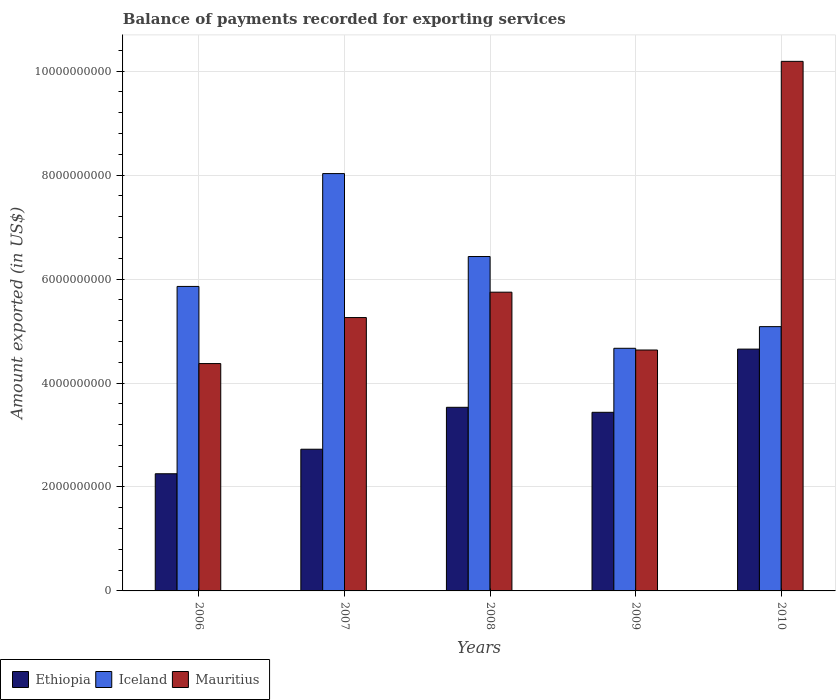How many bars are there on the 4th tick from the left?
Provide a short and direct response. 3. How many bars are there on the 2nd tick from the right?
Ensure brevity in your answer.  3. In how many cases, is the number of bars for a given year not equal to the number of legend labels?
Your answer should be very brief. 0. What is the amount exported in Mauritius in 2006?
Provide a short and direct response. 4.37e+09. Across all years, what is the maximum amount exported in Ethiopia?
Your response must be concise. 4.65e+09. Across all years, what is the minimum amount exported in Mauritius?
Your answer should be very brief. 4.37e+09. In which year was the amount exported in Ethiopia maximum?
Give a very brief answer. 2010. What is the total amount exported in Ethiopia in the graph?
Your answer should be very brief. 1.66e+1. What is the difference between the amount exported in Iceland in 2006 and that in 2007?
Your response must be concise. -2.17e+09. What is the difference between the amount exported in Ethiopia in 2007 and the amount exported in Mauritius in 2008?
Provide a short and direct response. -3.02e+09. What is the average amount exported in Iceland per year?
Offer a very short reply. 6.01e+09. In the year 2006, what is the difference between the amount exported in Ethiopia and amount exported in Mauritius?
Provide a succinct answer. -2.12e+09. In how many years, is the amount exported in Ethiopia greater than 9200000000 US$?
Provide a short and direct response. 0. What is the ratio of the amount exported in Ethiopia in 2006 to that in 2009?
Your response must be concise. 0.66. Is the amount exported in Mauritius in 2007 less than that in 2009?
Your answer should be very brief. No. What is the difference between the highest and the second highest amount exported in Ethiopia?
Keep it short and to the point. 1.12e+09. What is the difference between the highest and the lowest amount exported in Iceland?
Give a very brief answer. 3.36e+09. Is the sum of the amount exported in Iceland in 2007 and 2008 greater than the maximum amount exported in Mauritius across all years?
Make the answer very short. Yes. What does the 2nd bar from the left in 2008 represents?
Offer a very short reply. Iceland. What does the 1st bar from the right in 2007 represents?
Make the answer very short. Mauritius. How many bars are there?
Give a very brief answer. 15. What is the difference between two consecutive major ticks on the Y-axis?
Provide a short and direct response. 2.00e+09. Where does the legend appear in the graph?
Provide a succinct answer. Bottom left. How are the legend labels stacked?
Provide a short and direct response. Horizontal. What is the title of the graph?
Offer a terse response. Balance of payments recorded for exporting services. Does "Solomon Islands" appear as one of the legend labels in the graph?
Offer a terse response. No. What is the label or title of the Y-axis?
Keep it short and to the point. Amount exported (in US$). What is the Amount exported (in US$) in Ethiopia in 2006?
Ensure brevity in your answer.  2.25e+09. What is the Amount exported (in US$) of Iceland in 2006?
Provide a short and direct response. 5.86e+09. What is the Amount exported (in US$) in Mauritius in 2006?
Keep it short and to the point. 4.37e+09. What is the Amount exported (in US$) of Ethiopia in 2007?
Your answer should be very brief. 2.73e+09. What is the Amount exported (in US$) of Iceland in 2007?
Keep it short and to the point. 8.03e+09. What is the Amount exported (in US$) of Mauritius in 2007?
Offer a terse response. 5.26e+09. What is the Amount exported (in US$) in Ethiopia in 2008?
Your answer should be very brief. 3.53e+09. What is the Amount exported (in US$) of Iceland in 2008?
Keep it short and to the point. 6.43e+09. What is the Amount exported (in US$) of Mauritius in 2008?
Keep it short and to the point. 5.75e+09. What is the Amount exported (in US$) of Ethiopia in 2009?
Give a very brief answer. 3.44e+09. What is the Amount exported (in US$) of Iceland in 2009?
Ensure brevity in your answer.  4.67e+09. What is the Amount exported (in US$) of Mauritius in 2009?
Offer a terse response. 4.64e+09. What is the Amount exported (in US$) of Ethiopia in 2010?
Make the answer very short. 4.65e+09. What is the Amount exported (in US$) of Iceland in 2010?
Give a very brief answer. 5.08e+09. What is the Amount exported (in US$) in Mauritius in 2010?
Provide a succinct answer. 1.02e+1. Across all years, what is the maximum Amount exported (in US$) of Ethiopia?
Your answer should be compact. 4.65e+09. Across all years, what is the maximum Amount exported (in US$) in Iceland?
Offer a terse response. 8.03e+09. Across all years, what is the maximum Amount exported (in US$) in Mauritius?
Your answer should be very brief. 1.02e+1. Across all years, what is the minimum Amount exported (in US$) in Ethiopia?
Your answer should be very brief. 2.25e+09. Across all years, what is the minimum Amount exported (in US$) of Iceland?
Ensure brevity in your answer.  4.67e+09. Across all years, what is the minimum Amount exported (in US$) of Mauritius?
Your answer should be very brief. 4.37e+09. What is the total Amount exported (in US$) in Ethiopia in the graph?
Offer a terse response. 1.66e+1. What is the total Amount exported (in US$) in Iceland in the graph?
Your answer should be compact. 3.01e+1. What is the total Amount exported (in US$) in Mauritius in the graph?
Your answer should be very brief. 3.02e+1. What is the difference between the Amount exported (in US$) of Ethiopia in 2006 and that in 2007?
Give a very brief answer. -4.72e+08. What is the difference between the Amount exported (in US$) of Iceland in 2006 and that in 2007?
Your answer should be compact. -2.17e+09. What is the difference between the Amount exported (in US$) of Mauritius in 2006 and that in 2007?
Your response must be concise. -8.85e+08. What is the difference between the Amount exported (in US$) in Ethiopia in 2006 and that in 2008?
Your answer should be very brief. -1.28e+09. What is the difference between the Amount exported (in US$) in Iceland in 2006 and that in 2008?
Offer a terse response. -5.76e+08. What is the difference between the Amount exported (in US$) of Mauritius in 2006 and that in 2008?
Give a very brief answer. -1.37e+09. What is the difference between the Amount exported (in US$) in Ethiopia in 2006 and that in 2009?
Ensure brevity in your answer.  -1.18e+09. What is the difference between the Amount exported (in US$) of Iceland in 2006 and that in 2009?
Offer a very short reply. 1.19e+09. What is the difference between the Amount exported (in US$) of Mauritius in 2006 and that in 2009?
Provide a succinct answer. -2.61e+08. What is the difference between the Amount exported (in US$) in Ethiopia in 2006 and that in 2010?
Make the answer very short. -2.40e+09. What is the difference between the Amount exported (in US$) in Iceland in 2006 and that in 2010?
Offer a very short reply. 7.73e+08. What is the difference between the Amount exported (in US$) of Mauritius in 2006 and that in 2010?
Ensure brevity in your answer.  -5.81e+09. What is the difference between the Amount exported (in US$) in Ethiopia in 2007 and that in 2008?
Your answer should be very brief. -8.07e+08. What is the difference between the Amount exported (in US$) of Iceland in 2007 and that in 2008?
Offer a terse response. 1.60e+09. What is the difference between the Amount exported (in US$) of Mauritius in 2007 and that in 2008?
Your answer should be compact. -4.88e+08. What is the difference between the Amount exported (in US$) in Ethiopia in 2007 and that in 2009?
Offer a very short reply. -7.10e+08. What is the difference between the Amount exported (in US$) of Iceland in 2007 and that in 2009?
Keep it short and to the point. 3.36e+09. What is the difference between the Amount exported (in US$) of Mauritius in 2007 and that in 2009?
Keep it short and to the point. 6.24e+08. What is the difference between the Amount exported (in US$) in Ethiopia in 2007 and that in 2010?
Provide a short and direct response. -1.93e+09. What is the difference between the Amount exported (in US$) in Iceland in 2007 and that in 2010?
Ensure brevity in your answer.  2.94e+09. What is the difference between the Amount exported (in US$) in Mauritius in 2007 and that in 2010?
Give a very brief answer. -4.93e+09. What is the difference between the Amount exported (in US$) in Ethiopia in 2008 and that in 2009?
Your answer should be very brief. 9.64e+07. What is the difference between the Amount exported (in US$) of Iceland in 2008 and that in 2009?
Provide a succinct answer. 1.77e+09. What is the difference between the Amount exported (in US$) in Mauritius in 2008 and that in 2009?
Offer a terse response. 1.11e+09. What is the difference between the Amount exported (in US$) in Ethiopia in 2008 and that in 2010?
Your response must be concise. -1.12e+09. What is the difference between the Amount exported (in US$) of Iceland in 2008 and that in 2010?
Keep it short and to the point. 1.35e+09. What is the difference between the Amount exported (in US$) in Mauritius in 2008 and that in 2010?
Offer a very short reply. -4.44e+09. What is the difference between the Amount exported (in US$) in Ethiopia in 2009 and that in 2010?
Your response must be concise. -1.22e+09. What is the difference between the Amount exported (in US$) of Iceland in 2009 and that in 2010?
Ensure brevity in your answer.  -4.17e+08. What is the difference between the Amount exported (in US$) in Mauritius in 2009 and that in 2010?
Ensure brevity in your answer.  -5.55e+09. What is the difference between the Amount exported (in US$) of Ethiopia in 2006 and the Amount exported (in US$) of Iceland in 2007?
Make the answer very short. -5.77e+09. What is the difference between the Amount exported (in US$) in Ethiopia in 2006 and the Amount exported (in US$) in Mauritius in 2007?
Give a very brief answer. -3.01e+09. What is the difference between the Amount exported (in US$) in Iceland in 2006 and the Amount exported (in US$) in Mauritius in 2007?
Offer a very short reply. 5.99e+08. What is the difference between the Amount exported (in US$) in Ethiopia in 2006 and the Amount exported (in US$) in Iceland in 2008?
Provide a short and direct response. -4.18e+09. What is the difference between the Amount exported (in US$) of Ethiopia in 2006 and the Amount exported (in US$) of Mauritius in 2008?
Give a very brief answer. -3.49e+09. What is the difference between the Amount exported (in US$) in Iceland in 2006 and the Amount exported (in US$) in Mauritius in 2008?
Make the answer very short. 1.10e+08. What is the difference between the Amount exported (in US$) in Ethiopia in 2006 and the Amount exported (in US$) in Iceland in 2009?
Provide a short and direct response. -2.41e+09. What is the difference between the Amount exported (in US$) of Ethiopia in 2006 and the Amount exported (in US$) of Mauritius in 2009?
Keep it short and to the point. -2.38e+09. What is the difference between the Amount exported (in US$) in Iceland in 2006 and the Amount exported (in US$) in Mauritius in 2009?
Offer a terse response. 1.22e+09. What is the difference between the Amount exported (in US$) of Ethiopia in 2006 and the Amount exported (in US$) of Iceland in 2010?
Provide a short and direct response. -2.83e+09. What is the difference between the Amount exported (in US$) in Ethiopia in 2006 and the Amount exported (in US$) in Mauritius in 2010?
Your answer should be compact. -7.93e+09. What is the difference between the Amount exported (in US$) in Iceland in 2006 and the Amount exported (in US$) in Mauritius in 2010?
Provide a succinct answer. -4.33e+09. What is the difference between the Amount exported (in US$) of Ethiopia in 2007 and the Amount exported (in US$) of Iceland in 2008?
Your answer should be very brief. -3.71e+09. What is the difference between the Amount exported (in US$) of Ethiopia in 2007 and the Amount exported (in US$) of Mauritius in 2008?
Your response must be concise. -3.02e+09. What is the difference between the Amount exported (in US$) of Iceland in 2007 and the Amount exported (in US$) of Mauritius in 2008?
Offer a terse response. 2.28e+09. What is the difference between the Amount exported (in US$) of Ethiopia in 2007 and the Amount exported (in US$) of Iceland in 2009?
Provide a short and direct response. -1.94e+09. What is the difference between the Amount exported (in US$) in Ethiopia in 2007 and the Amount exported (in US$) in Mauritius in 2009?
Keep it short and to the point. -1.91e+09. What is the difference between the Amount exported (in US$) in Iceland in 2007 and the Amount exported (in US$) in Mauritius in 2009?
Make the answer very short. 3.39e+09. What is the difference between the Amount exported (in US$) of Ethiopia in 2007 and the Amount exported (in US$) of Iceland in 2010?
Offer a very short reply. -2.36e+09. What is the difference between the Amount exported (in US$) of Ethiopia in 2007 and the Amount exported (in US$) of Mauritius in 2010?
Ensure brevity in your answer.  -7.46e+09. What is the difference between the Amount exported (in US$) of Iceland in 2007 and the Amount exported (in US$) of Mauritius in 2010?
Your response must be concise. -2.16e+09. What is the difference between the Amount exported (in US$) in Ethiopia in 2008 and the Amount exported (in US$) in Iceland in 2009?
Your response must be concise. -1.14e+09. What is the difference between the Amount exported (in US$) in Ethiopia in 2008 and the Amount exported (in US$) in Mauritius in 2009?
Ensure brevity in your answer.  -1.10e+09. What is the difference between the Amount exported (in US$) of Iceland in 2008 and the Amount exported (in US$) of Mauritius in 2009?
Keep it short and to the point. 1.80e+09. What is the difference between the Amount exported (in US$) in Ethiopia in 2008 and the Amount exported (in US$) in Iceland in 2010?
Give a very brief answer. -1.55e+09. What is the difference between the Amount exported (in US$) of Ethiopia in 2008 and the Amount exported (in US$) of Mauritius in 2010?
Offer a very short reply. -6.66e+09. What is the difference between the Amount exported (in US$) of Iceland in 2008 and the Amount exported (in US$) of Mauritius in 2010?
Ensure brevity in your answer.  -3.75e+09. What is the difference between the Amount exported (in US$) of Ethiopia in 2009 and the Amount exported (in US$) of Iceland in 2010?
Your answer should be compact. -1.65e+09. What is the difference between the Amount exported (in US$) of Ethiopia in 2009 and the Amount exported (in US$) of Mauritius in 2010?
Give a very brief answer. -6.75e+09. What is the difference between the Amount exported (in US$) in Iceland in 2009 and the Amount exported (in US$) in Mauritius in 2010?
Offer a very short reply. -5.52e+09. What is the average Amount exported (in US$) of Ethiopia per year?
Ensure brevity in your answer.  3.32e+09. What is the average Amount exported (in US$) of Iceland per year?
Provide a short and direct response. 6.01e+09. What is the average Amount exported (in US$) in Mauritius per year?
Provide a succinct answer. 6.04e+09. In the year 2006, what is the difference between the Amount exported (in US$) in Ethiopia and Amount exported (in US$) in Iceland?
Ensure brevity in your answer.  -3.60e+09. In the year 2006, what is the difference between the Amount exported (in US$) in Ethiopia and Amount exported (in US$) in Mauritius?
Ensure brevity in your answer.  -2.12e+09. In the year 2006, what is the difference between the Amount exported (in US$) in Iceland and Amount exported (in US$) in Mauritius?
Offer a terse response. 1.48e+09. In the year 2007, what is the difference between the Amount exported (in US$) in Ethiopia and Amount exported (in US$) in Iceland?
Offer a very short reply. -5.30e+09. In the year 2007, what is the difference between the Amount exported (in US$) in Ethiopia and Amount exported (in US$) in Mauritius?
Offer a terse response. -2.53e+09. In the year 2007, what is the difference between the Amount exported (in US$) of Iceland and Amount exported (in US$) of Mauritius?
Offer a very short reply. 2.77e+09. In the year 2008, what is the difference between the Amount exported (in US$) in Ethiopia and Amount exported (in US$) in Iceland?
Your answer should be compact. -2.90e+09. In the year 2008, what is the difference between the Amount exported (in US$) of Ethiopia and Amount exported (in US$) of Mauritius?
Provide a succinct answer. -2.21e+09. In the year 2008, what is the difference between the Amount exported (in US$) of Iceland and Amount exported (in US$) of Mauritius?
Keep it short and to the point. 6.86e+08. In the year 2009, what is the difference between the Amount exported (in US$) in Ethiopia and Amount exported (in US$) in Iceland?
Ensure brevity in your answer.  -1.23e+09. In the year 2009, what is the difference between the Amount exported (in US$) in Ethiopia and Amount exported (in US$) in Mauritius?
Your answer should be compact. -1.20e+09. In the year 2009, what is the difference between the Amount exported (in US$) of Iceland and Amount exported (in US$) of Mauritius?
Provide a succinct answer. 3.30e+07. In the year 2010, what is the difference between the Amount exported (in US$) of Ethiopia and Amount exported (in US$) of Iceland?
Your answer should be very brief. -4.32e+08. In the year 2010, what is the difference between the Amount exported (in US$) in Ethiopia and Amount exported (in US$) in Mauritius?
Offer a very short reply. -5.54e+09. In the year 2010, what is the difference between the Amount exported (in US$) in Iceland and Amount exported (in US$) in Mauritius?
Provide a succinct answer. -5.10e+09. What is the ratio of the Amount exported (in US$) in Ethiopia in 2006 to that in 2007?
Make the answer very short. 0.83. What is the ratio of the Amount exported (in US$) in Iceland in 2006 to that in 2007?
Provide a succinct answer. 0.73. What is the ratio of the Amount exported (in US$) in Mauritius in 2006 to that in 2007?
Your answer should be very brief. 0.83. What is the ratio of the Amount exported (in US$) in Ethiopia in 2006 to that in 2008?
Provide a succinct answer. 0.64. What is the ratio of the Amount exported (in US$) of Iceland in 2006 to that in 2008?
Keep it short and to the point. 0.91. What is the ratio of the Amount exported (in US$) in Mauritius in 2006 to that in 2008?
Give a very brief answer. 0.76. What is the ratio of the Amount exported (in US$) of Ethiopia in 2006 to that in 2009?
Your answer should be very brief. 0.66. What is the ratio of the Amount exported (in US$) in Iceland in 2006 to that in 2009?
Keep it short and to the point. 1.25. What is the ratio of the Amount exported (in US$) in Mauritius in 2006 to that in 2009?
Your answer should be very brief. 0.94. What is the ratio of the Amount exported (in US$) of Ethiopia in 2006 to that in 2010?
Offer a very short reply. 0.48. What is the ratio of the Amount exported (in US$) of Iceland in 2006 to that in 2010?
Provide a succinct answer. 1.15. What is the ratio of the Amount exported (in US$) in Mauritius in 2006 to that in 2010?
Keep it short and to the point. 0.43. What is the ratio of the Amount exported (in US$) of Ethiopia in 2007 to that in 2008?
Offer a very short reply. 0.77. What is the ratio of the Amount exported (in US$) of Iceland in 2007 to that in 2008?
Offer a terse response. 1.25. What is the ratio of the Amount exported (in US$) of Mauritius in 2007 to that in 2008?
Your answer should be compact. 0.92. What is the ratio of the Amount exported (in US$) of Ethiopia in 2007 to that in 2009?
Give a very brief answer. 0.79. What is the ratio of the Amount exported (in US$) of Iceland in 2007 to that in 2009?
Provide a succinct answer. 1.72. What is the ratio of the Amount exported (in US$) of Mauritius in 2007 to that in 2009?
Keep it short and to the point. 1.13. What is the ratio of the Amount exported (in US$) of Ethiopia in 2007 to that in 2010?
Ensure brevity in your answer.  0.59. What is the ratio of the Amount exported (in US$) of Iceland in 2007 to that in 2010?
Your answer should be compact. 1.58. What is the ratio of the Amount exported (in US$) of Mauritius in 2007 to that in 2010?
Keep it short and to the point. 0.52. What is the ratio of the Amount exported (in US$) of Ethiopia in 2008 to that in 2009?
Your answer should be compact. 1.03. What is the ratio of the Amount exported (in US$) of Iceland in 2008 to that in 2009?
Make the answer very short. 1.38. What is the ratio of the Amount exported (in US$) of Mauritius in 2008 to that in 2009?
Your response must be concise. 1.24. What is the ratio of the Amount exported (in US$) of Ethiopia in 2008 to that in 2010?
Your answer should be compact. 0.76. What is the ratio of the Amount exported (in US$) in Iceland in 2008 to that in 2010?
Provide a short and direct response. 1.27. What is the ratio of the Amount exported (in US$) in Mauritius in 2008 to that in 2010?
Your answer should be compact. 0.56. What is the ratio of the Amount exported (in US$) in Ethiopia in 2009 to that in 2010?
Your answer should be compact. 0.74. What is the ratio of the Amount exported (in US$) of Iceland in 2009 to that in 2010?
Make the answer very short. 0.92. What is the ratio of the Amount exported (in US$) in Mauritius in 2009 to that in 2010?
Provide a succinct answer. 0.45. What is the difference between the highest and the second highest Amount exported (in US$) in Ethiopia?
Provide a short and direct response. 1.12e+09. What is the difference between the highest and the second highest Amount exported (in US$) of Iceland?
Ensure brevity in your answer.  1.60e+09. What is the difference between the highest and the second highest Amount exported (in US$) of Mauritius?
Provide a succinct answer. 4.44e+09. What is the difference between the highest and the lowest Amount exported (in US$) in Ethiopia?
Offer a very short reply. 2.40e+09. What is the difference between the highest and the lowest Amount exported (in US$) in Iceland?
Provide a succinct answer. 3.36e+09. What is the difference between the highest and the lowest Amount exported (in US$) of Mauritius?
Your answer should be very brief. 5.81e+09. 